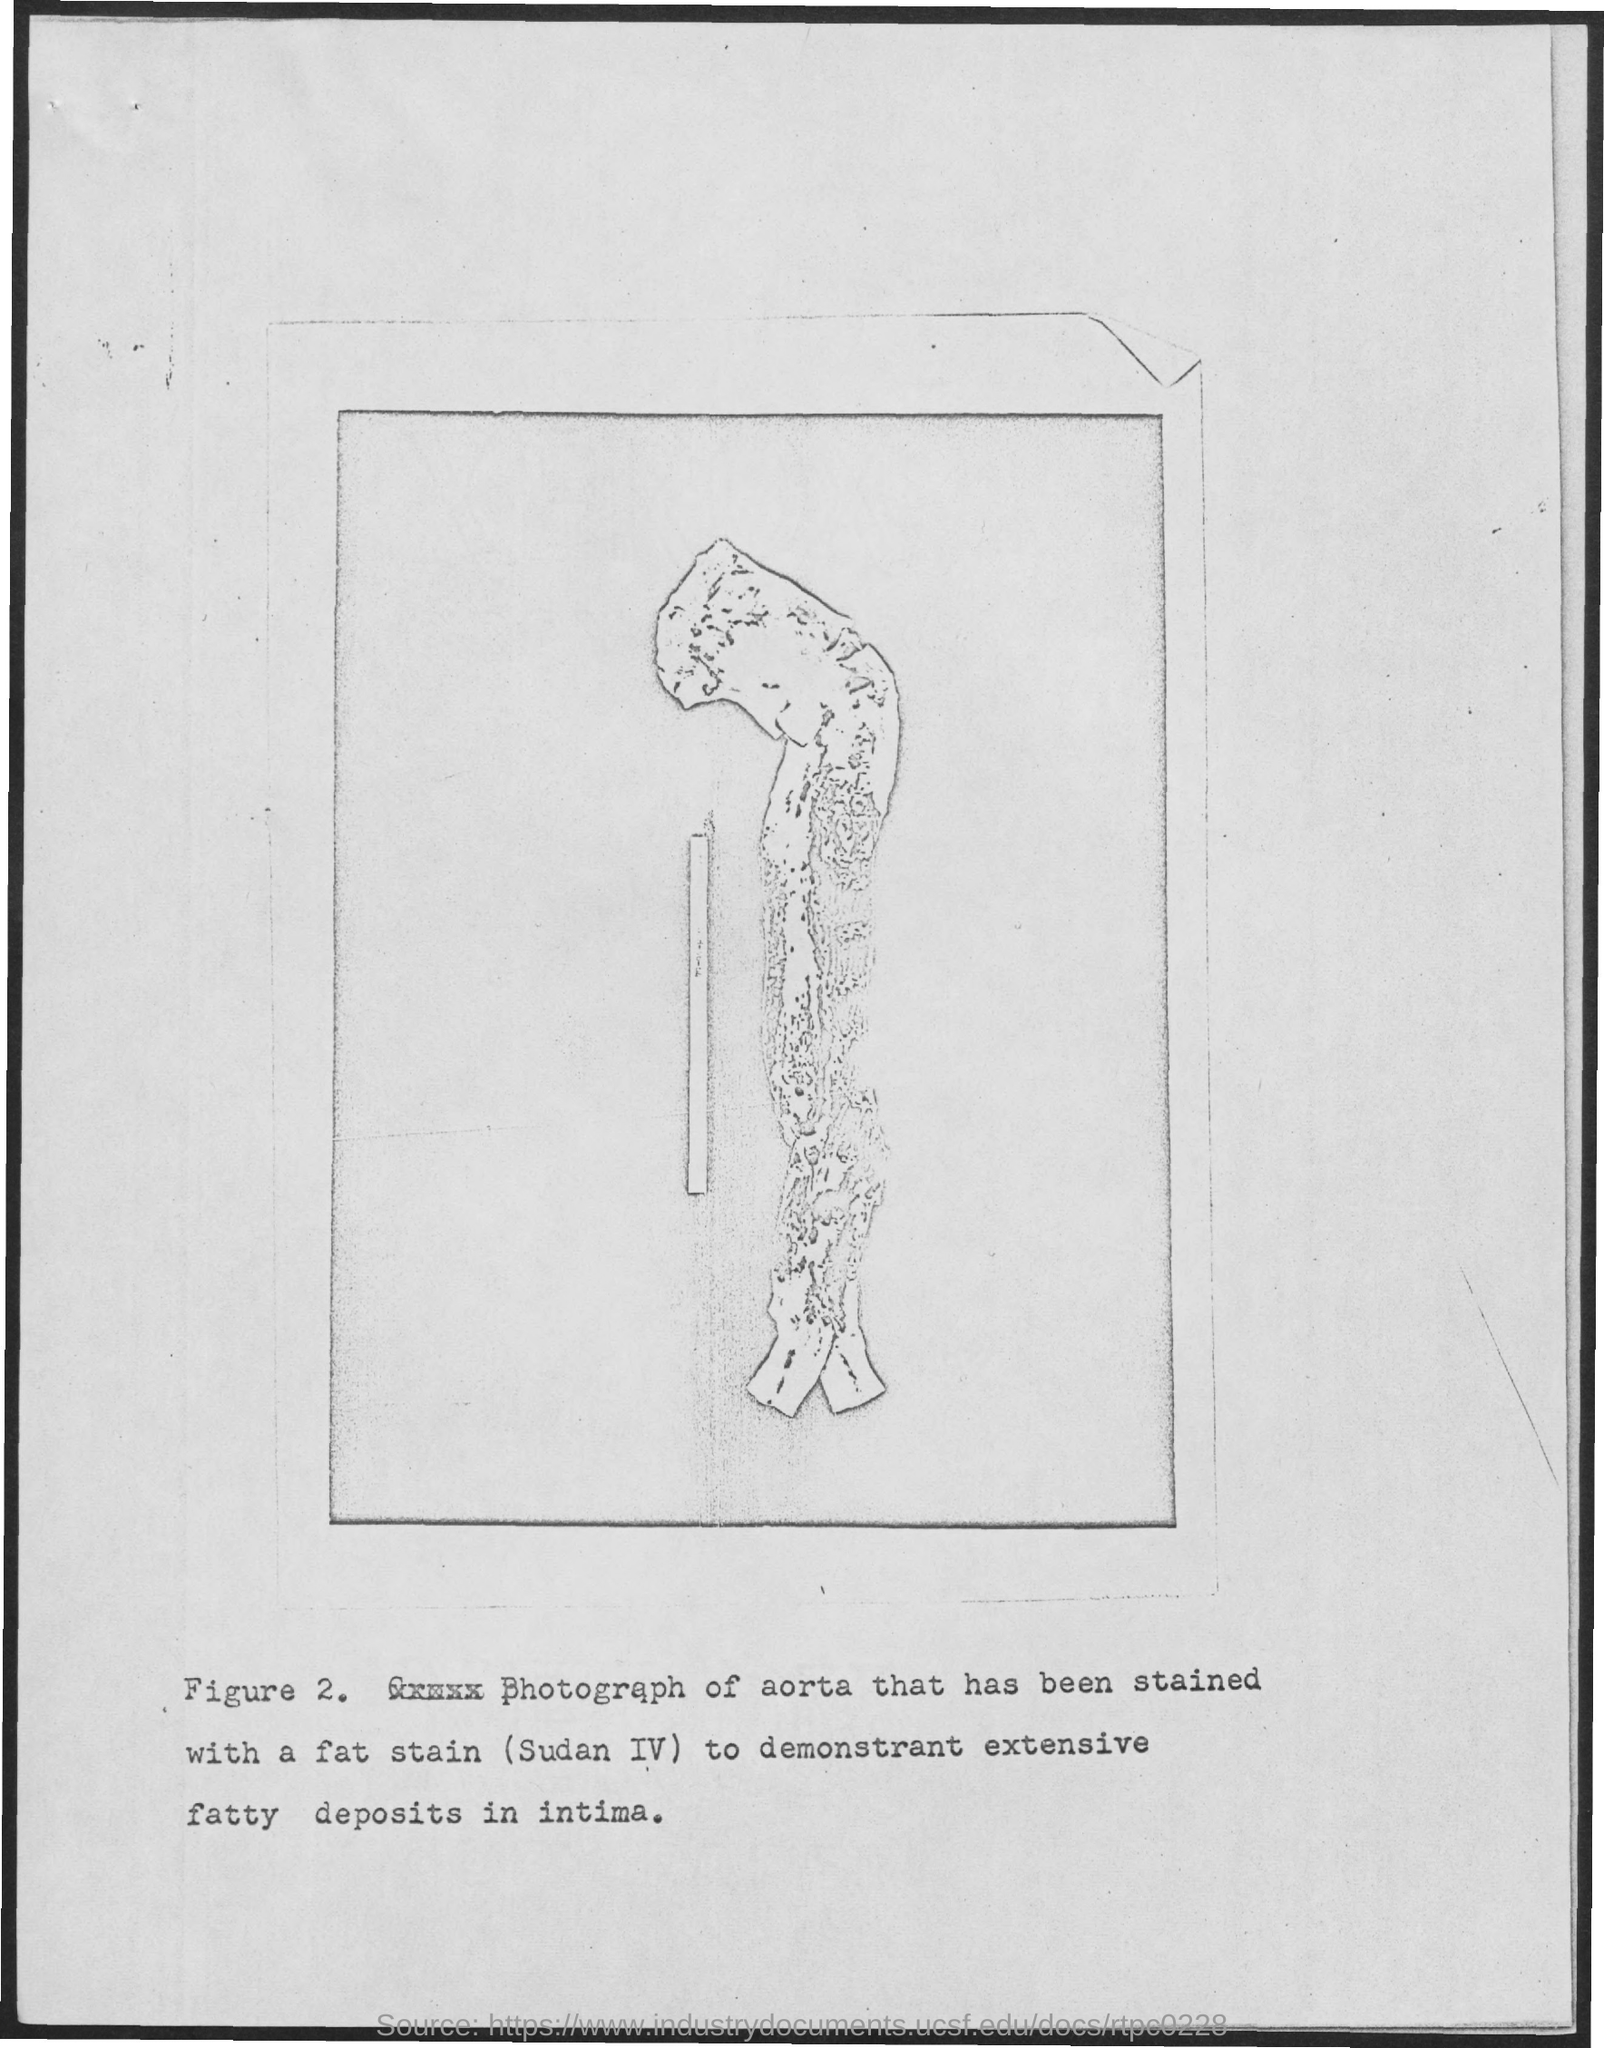Mention a couple of crucial points in this snapshot. The number of figures is two. 